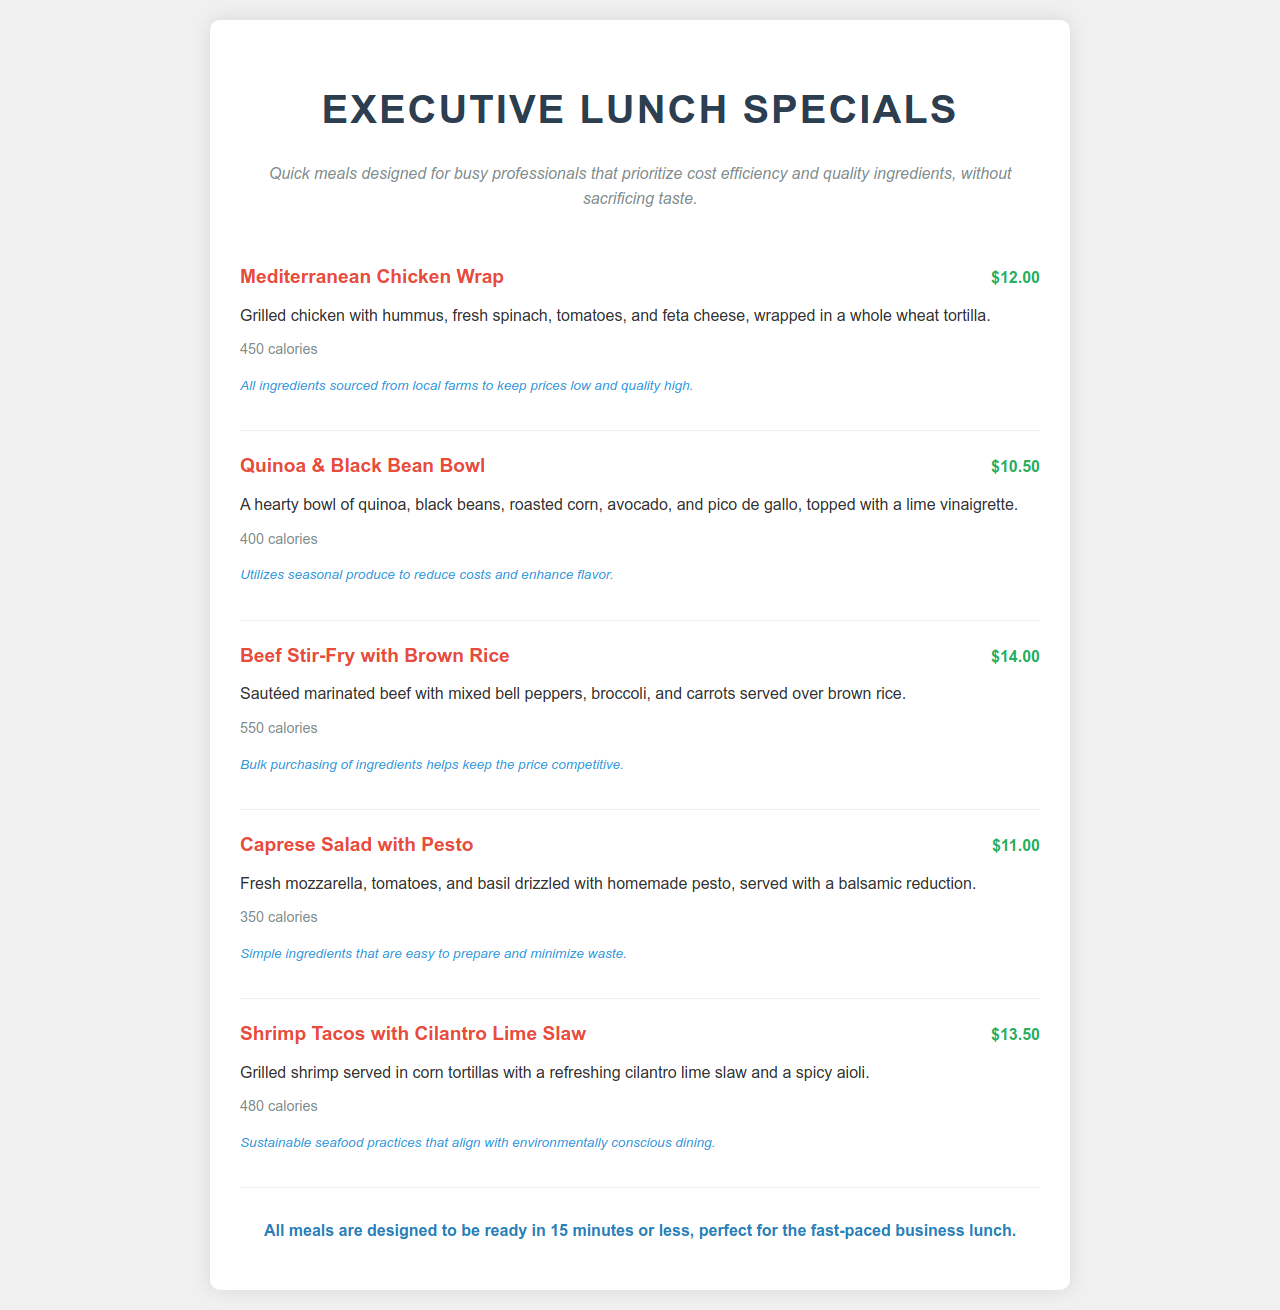What is the price of the Mediterranean Chicken Wrap? The Mediterranean Chicken Wrap is listed with a price of $12.00 in the menu.
Answer: $12.00 How many calories are in the Quinoa & Black Bean Bowl? The calorie count listed for the Quinoa & Black Bean Bowl is 400 calories.
Answer: 400 calories Which dish contains shrimp? The menu specifically mentions Shrimp Tacos with Cilantro Lime Slaw as the dish containing shrimp.
Answer: Shrimp Tacos with Cilantro Lime Slaw What is the main ingredient in the Caprese Salad? Fresh mozzarella is highlighted as a key ingredient in the Caprese Salad with Pesto.
Answer: Fresh mozzarella Which meal is the lowest priced? A quick comparison of the prices shows that the Quinoa & Black Bean Bowl is the lowest, priced at $10.50.
Answer: $10.50 What is emphasized about the sourcing of ingredients in the Mediterranean Chicken Wrap? It mentions that all ingredients are sourced from local farms to maintain low prices and high quality.
Answer: Local farms How long does it take to prepare all meals? The document notes that all meals are designed to be ready in 15 minutes or less.
Answer: 15 minutes What type of dietary consideration is addressed in the Shrimp Tacos description? The menu mentions sustainable seafood practices in the context of the Shrimp Tacos with Cilantro Lime Slaw.
Answer: Sustainable seafood practices What dressing is used in the Quinoa & Black Bean Bowl? A lime vinaigrette is specified as the dressing for the Quinoa & Black Bean Bowl.
Answer: Lime vinaigrette 